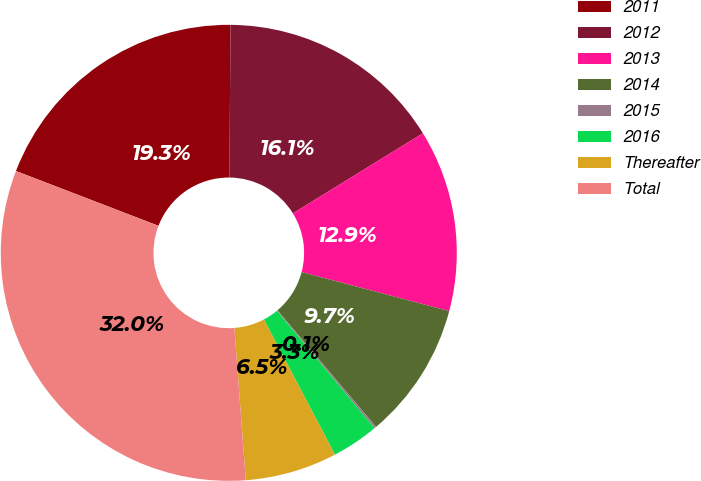<chart> <loc_0><loc_0><loc_500><loc_500><pie_chart><fcel>2011<fcel>2012<fcel>2013<fcel>2014<fcel>2015<fcel>2016<fcel>Thereafter<fcel>Total<nl><fcel>19.28%<fcel>16.09%<fcel>12.9%<fcel>9.71%<fcel>0.14%<fcel>3.33%<fcel>6.52%<fcel>32.03%<nl></chart> 